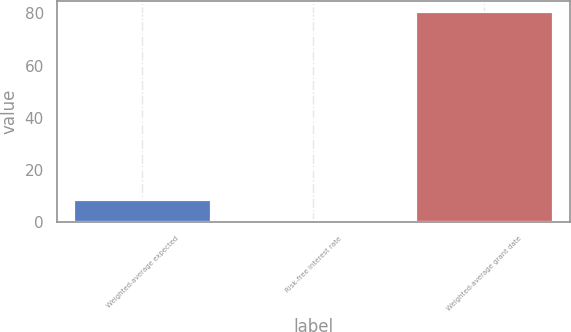Convert chart. <chart><loc_0><loc_0><loc_500><loc_500><bar_chart><fcel>Weighted-average expected<fcel>Risk-free interest rate<fcel>Weighted-average grant date<nl><fcel>8.69<fcel>0.7<fcel>80.59<nl></chart> 